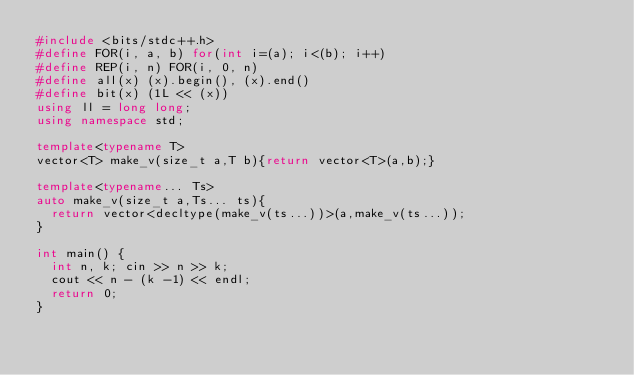Convert code to text. <code><loc_0><loc_0><loc_500><loc_500><_C++_>#include <bits/stdc++.h>
#define FOR(i, a, b) for(int i=(a); i<(b); i++)
#define REP(i, n) FOR(i, 0, n)
#define all(x) (x).begin(), (x).end()
#define bit(x) (1L << (x))
using ll = long long;
using namespace std;

template<typename T>
vector<T> make_v(size_t a,T b){return vector<T>(a,b);}
 
template<typename... Ts>
auto make_v(size_t a,Ts... ts){
  return vector<decltype(make_v(ts...))>(a,make_v(ts...));
}

int main() {
  int n, k; cin >> n >> k;
  cout << n - (k -1) << endl;
  return 0;
}
</code> 